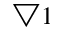<formula> <loc_0><loc_0><loc_500><loc_500>\bigtriangledown 1</formula> 